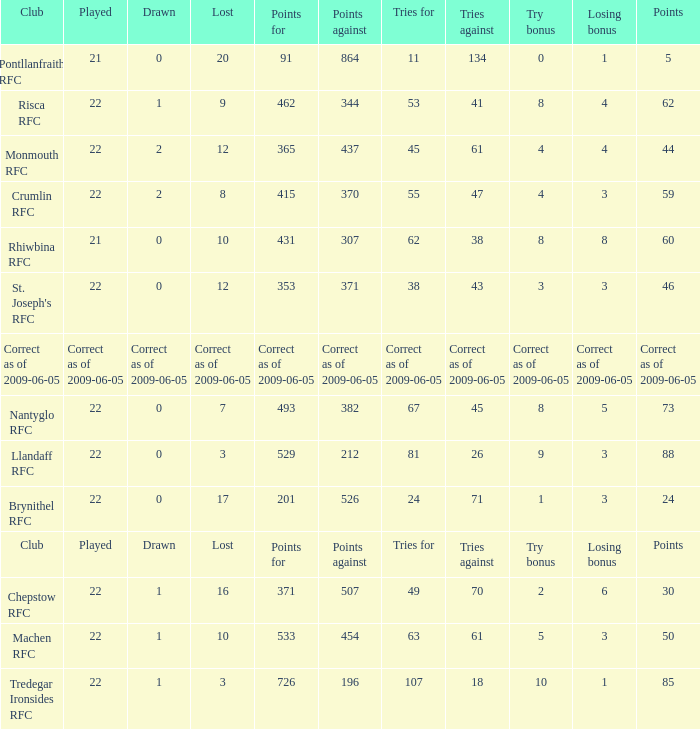What's the losing bonus of Crumlin RFC? 3.0. 